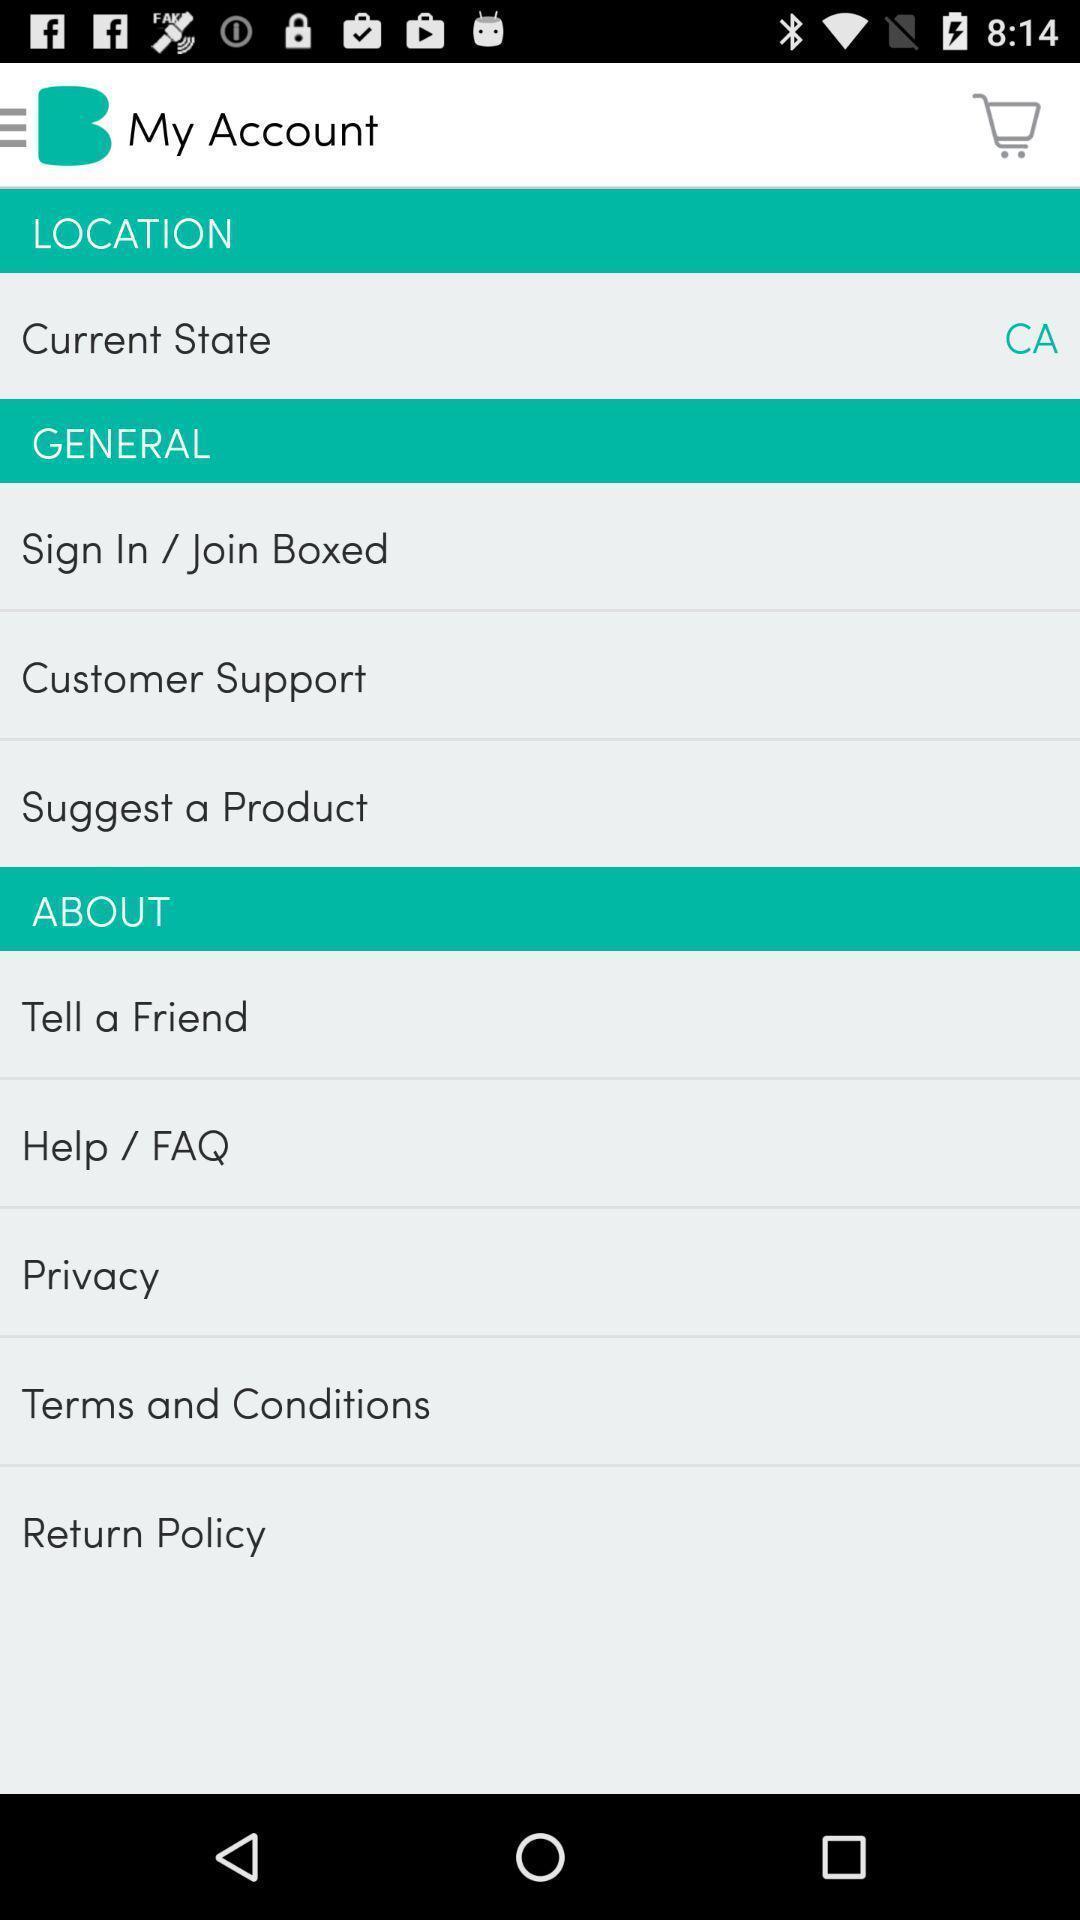Provide a description of this screenshot. Page displaying account details and other options in shopping application. 